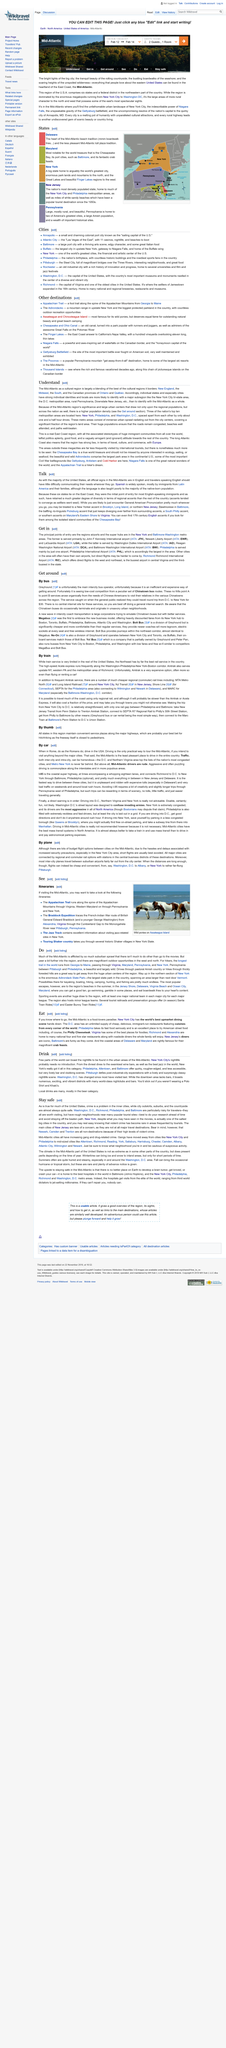Specify some key components in this picture. The title "Does this title tell the summary of what is written in the paragraph? No, it does not..." does not accurately convey the information presented in the paragraph. The IATA for LaGuardia Airport is LGA. Reagan Washington National Airport is represented by the IATA code DCA, which stands for "DCA" in full. 